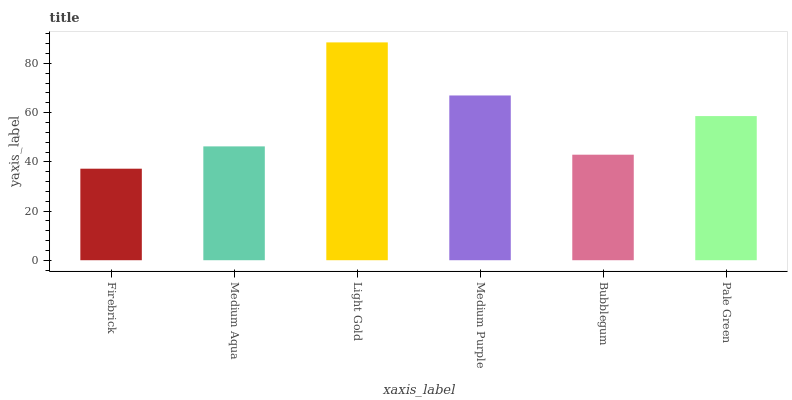Is Firebrick the minimum?
Answer yes or no. Yes. Is Light Gold the maximum?
Answer yes or no. Yes. Is Medium Aqua the minimum?
Answer yes or no. No. Is Medium Aqua the maximum?
Answer yes or no. No. Is Medium Aqua greater than Firebrick?
Answer yes or no. Yes. Is Firebrick less than Medium Aqua?
Answer yes or no. Yes. Is Firebrick greater than Medium Aqua?
Answer yes or no. No. Is Medium Aqua less than Firebrick?
Answer yes or no. No. Is Pale Green the high median?
Answer yes or no. Yes. Is Medium Aqua the low median?
Answer yes or no. Yes. Is Medium Aqua the high median?
Answer yes or no. No. Is Firebrick the low median?
Answer yes or no. No. 